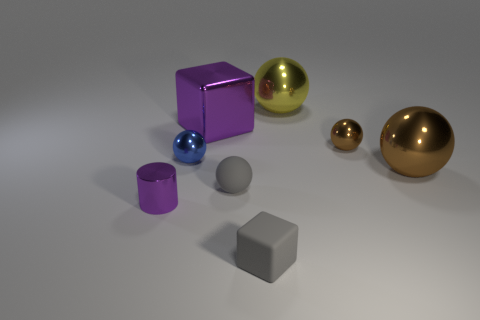There is a small matte thing that is right of the gray rubber sphere; what number of small objects are to the right of it?
Make the answer very short. 1. Does the metal cylinder have the same color as the thing in front of the purple metallic cylinder?
Provide a short and direct response. No. What number of green rubber objects are the same shape as the large yellow thing?
Make the answer very short. 0. There is a large ball behind the tiny brown metal thing; what material is it?
Offer a very short reply. Metal. There is a tiny gray matte thing that is in front of the tiny purple shiny cylinder; is its shape the same as the yellow thing?
Give a very brief answer. No. Is there a gray matte cube that has the same size as the yellow metallic object?
Your answer should be very brief. No. Is the shape of the large yellow metal object the same as the small shiny object right of the tiny rubber sphere?
Your answer should be very brief. Yes. There is a large thing that is the same color as the small metallic cylinder; what is its shape?
Provide a succinct answer. Cube. Are there fewer small purple cylinders that are on the right side of the big yellow thing than yellow balls?
Provide a short and direct response. Yes. Is the blue thing the same shape as the large purple object?
Provide a short and direct response. No. 